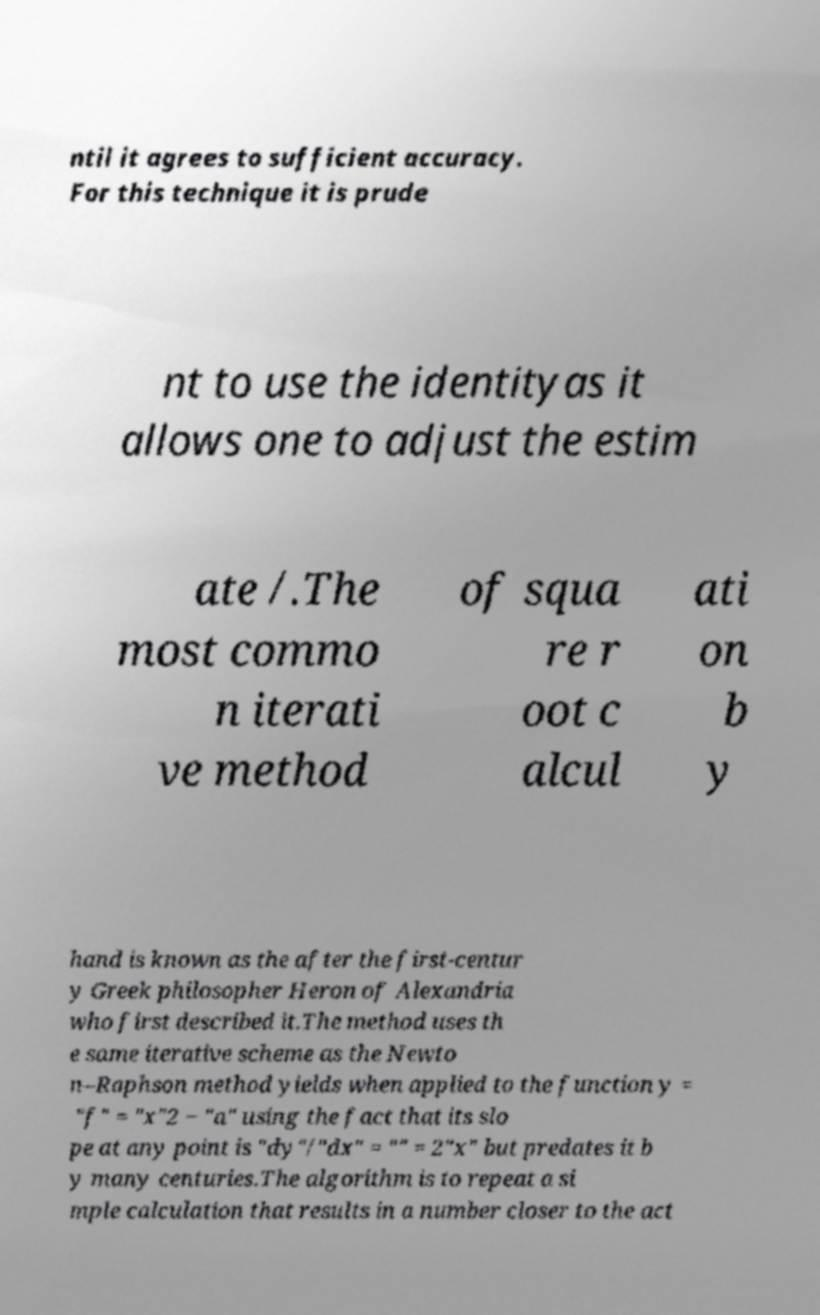What messages or text are displayed in this image? I need them in a readable, typed format. ntil it agrees to sufficient accuracy. For this technique it is prude nt to use the identityas it allows one to adjust the estim ate /.The most commo n iterati ve method of squa re r oot c alcul ati on b y hand is known as the after the first-centur y Greek philosopher Heron of Alexandria who first described it.The method uses th e same iterative scheme as the Newto n–Raphson method yields when applied to the function y = "f" = "x"2 − "a" using the fact that its slo pe at any point is "dy"/"dx" = "" = 2"x" but predates it b y many centuries.The algorithm is to repeat a si mple calculation that results in a number closer to the act 